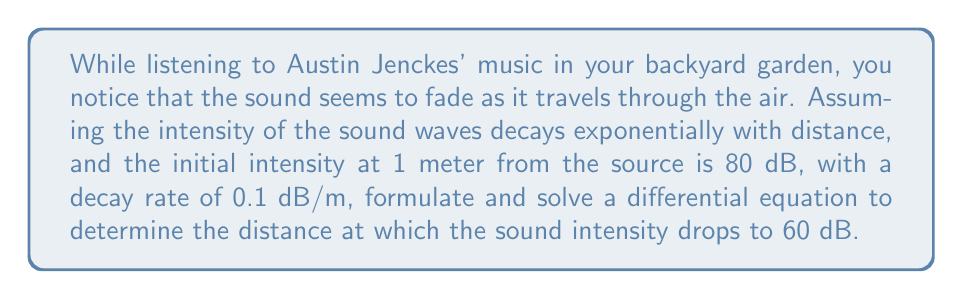Could you help me with this problem? Let's approach this problem step-by-step:

1) Let $I(x)$ be the intensity of the sound at distance $x$ meters from the source.

2) The decay rate is exponential, so we can model this with the differential equation:

   $$\frac{dI}{dx} = -kI$$

   where $k$ is the decay constant.

3) We're given that the decay rate is 0.1 dB/m. However, we need to convert this to a proportional decay rate. In the decibel scale, a decrease of 10 dB corresponds to a factor of 10 decrease in intensity. So, a 0.1 dB/m decay rate corresponds to a proportional decay rate of:

   $$k = 1 - 10^{-0.1/10} \approx 0.0230$$

4) The general solution to the differential equation is:

   $$I(x) = I_0e^{-kx}$$

   where $I_0$ is the initial intensity at $x = 1$ meter.

5) We're given $I_0 = 80$ dB. We need to find $x$ when $I(x) = 60$ dB.

6) Substituting these values:

   $$60 = 80e^{-0.0230x}$$

7) Taking the natural log of both sides:

   $$\ln(60/80) = -0.0230x$$

8) Solving for $x$:

   $$x = \frac{\ln(60/80)}{-0.0230} \approx 36.23$$

Therefore, the sound intensity drops to 60 dB at approximately 36.23 meters from the source.
Answer: The sound intensity drops to 60 dB at approximately 36.23 meters from the source. 